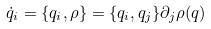Convert formula to latex. <formula><loc_0><loc_0><loc_500><loc_500>\dot { q } _ { i } = \{ q _ { i } , \rho \} = \{ q _ { i } , q _ { j } \} \partial _ { j } \rho ( q )</formula> 